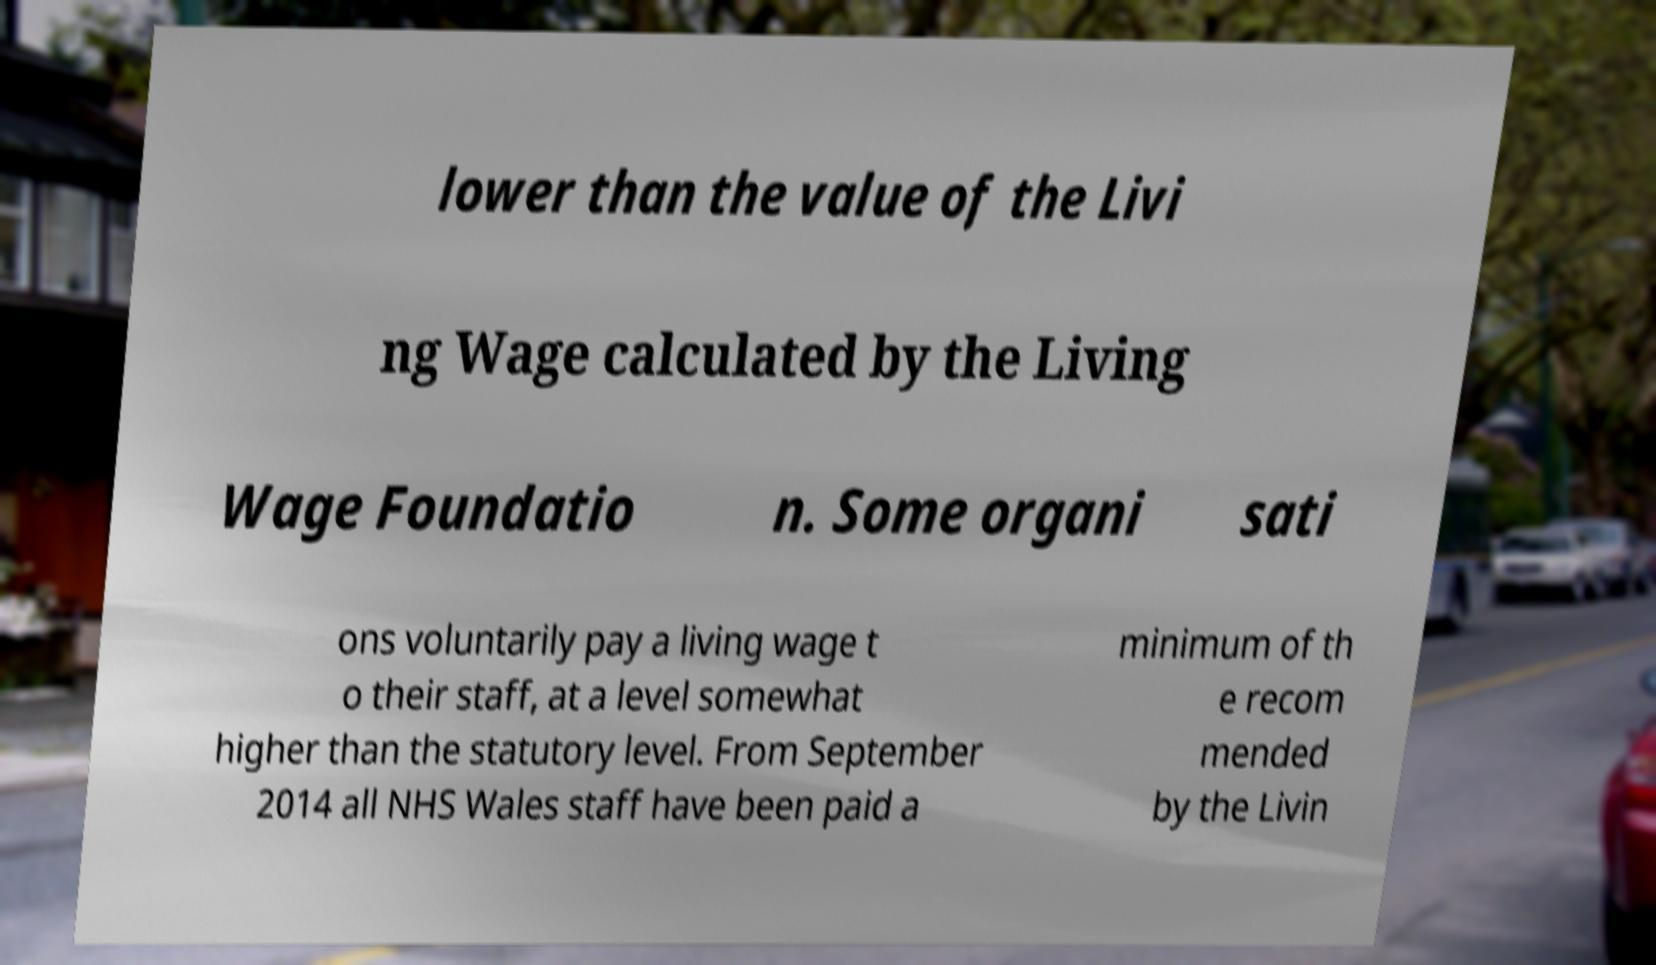Could you assist in decoding the text presented in this image and type it out clearly? lower than the value of the Livi ng Wage calculated by the Living Wage Foundatio n. Some organi sati ons voluntarily pay a living wage t o their staff, at a level somewhat higher than the statutory level. From September 2014 all NHS Wales staff have been paid a minimum of th e recom mended by the Livin 